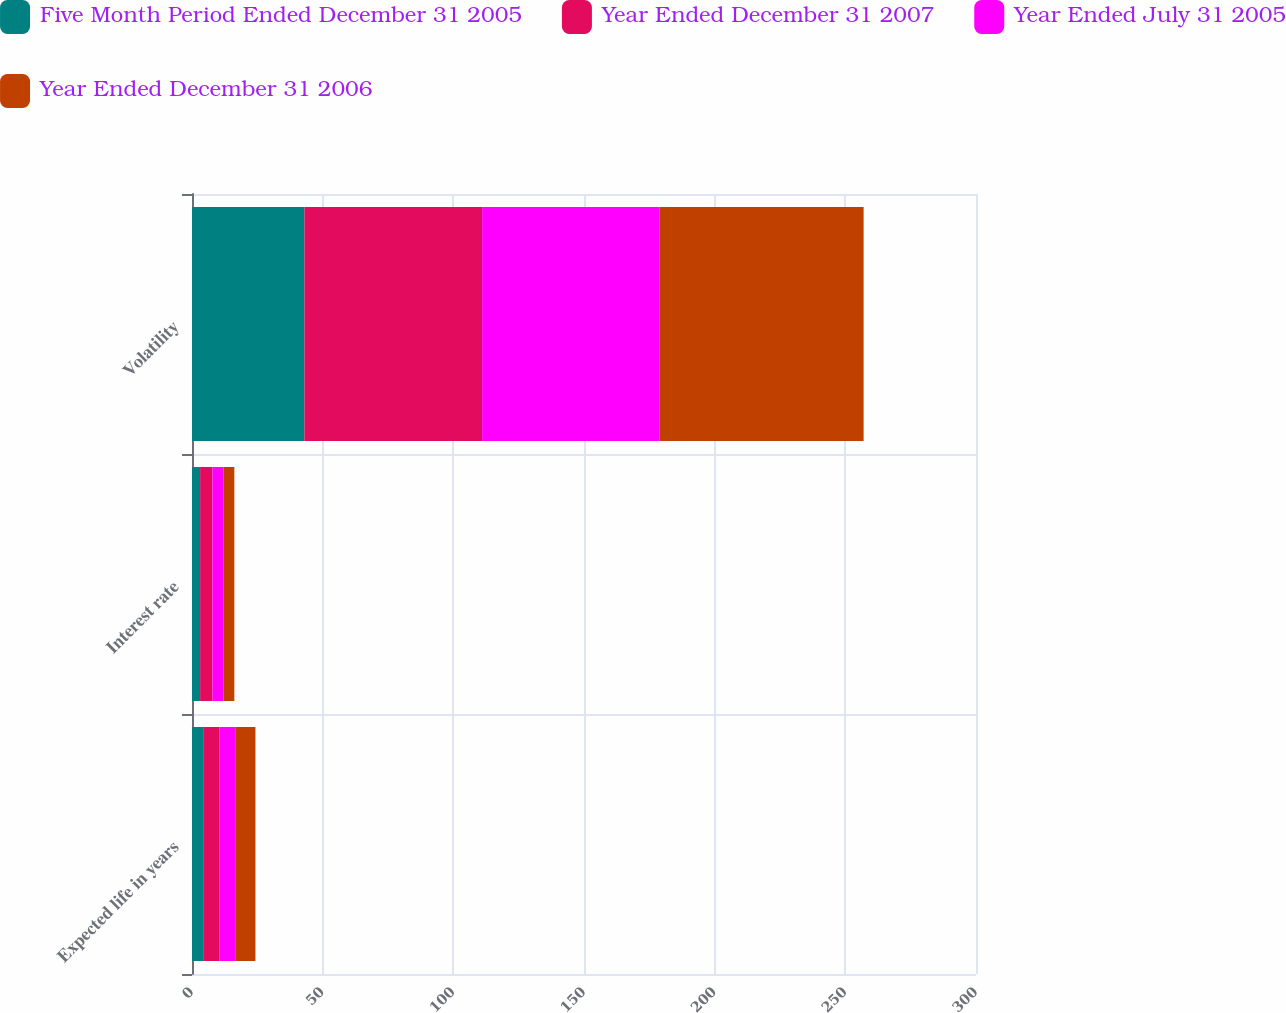Convert chart. <chart><loc_0><loc_0><loc_500><loc_500><stacked_bar_chart><ecel><fcel>Expected life in years<fcel>Interest rate<fcel>Volatility<nl><fcel>Five Month Period Ended December 31 2005<fcel>4.28<fcel>3.1<fcel>43<nl><fcel>Year Ended December 31 2007<fcel>6.25<fcel>4.7<fcel>68<nl><fcel>Year Ended July 31 2005<fcel>6.25<fcel>4.3<fcel>68<nl><fcel>Year Ended December 31 2006<fcel>7.5<fcel>4.1<fcel>78<nl></chart> 